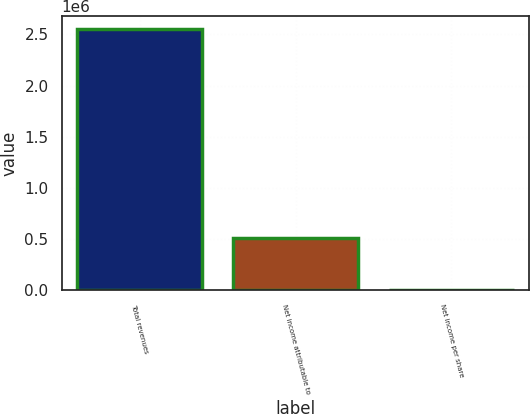Convert chart. <chart><loc_0><loc_0><loc_500><loc_500><bar_chart><fcel>Total revenues<fcel>Net income attributable to<fcel>Net income per share<nl><fcel>2.55424e+06<fcel>510850<fcel>3.37<nl></chart> 